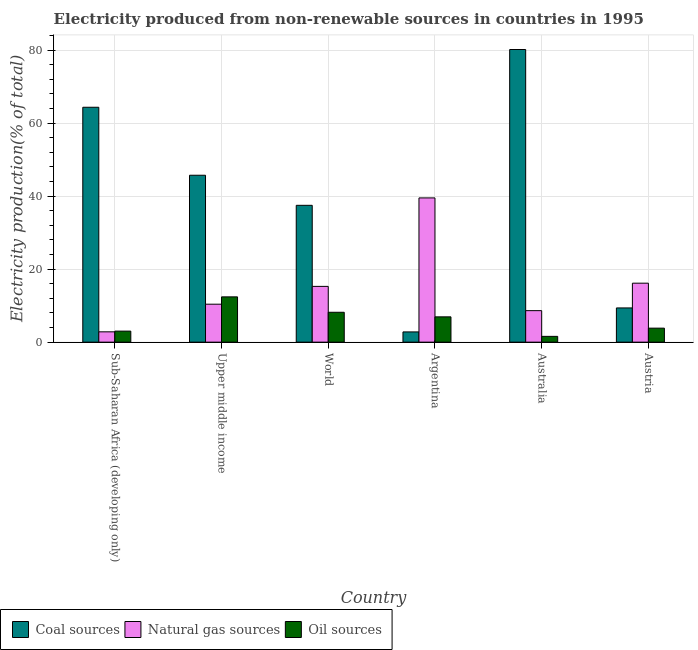How many different coloured bars are there?
Make the answer very short. 3. Are the number of bars per tick equal to the number of legend labels?
Ensure brevity in your answer.  Yes. How many bars are there on the 5th tick from the right?
Provide a short and direct response. 3. What is the label of the 5th group of bars from the left?
Offer a terse response. Australia. In how many cases, is the number of bars for a given country not equal to the number of legend labels?
Your response must be concise. 0. What is the percentage of electricity produced by natural gas in Austria?
Provide a short and direct response. 16.15. Across all countries, what is the maximum percentage of electricity produced by natural gas?
Ensure brevity in your answer.  39.51. Across all countries, what is the minimum percentage of electricity produced by coal?
Keep it short and to the point. 2.8. In which country was the percentage of electricity produced by natural gas minimum?
Your answer should be compact. Sub-Saharan Africa (developing only). What is the total percentage of electricity produced by oil sources in the graph?
Ensure brevity in your answer.  35.96. What is the difference between the percentage of electricity produced by oil sources in Upper middle income and that in World?
Your answer should be compact. 4.22. What is the difference between the percentage of electricity produced by natural gas in Argentina and the percentage of electricity produced by oil sources in Sub-Saharan Africa (developing only)?
Give a very brief answer. 36.49. What is the average percentage of electricity produced by coal per country?
Give a very brief answer. 39.98. What is the difference between the percentage of electricity produced by oil sources and percentage of electricity produced by natural gas in Austria?
Provide a succinct answer. -12.31. In how many countries, is the percentage of electricity produced by coal greater than 56 %?
Ensure brevity in your answer.  2. What is the ratio of the percentage of electricity produced by coal in Upper middle income to that in World?
Your answer should be compact. 1.22. Is the percentage of electricity produced by coal in Australia less than that in Sub-Saharan Africa (developing only)?
Give a very brief answer. No. What is the difference between the highest and the second highest percentage of electricity produced by coal?
Ensure brevity in your answer.  15.82. What is the difference between the highest and the lowest percentage of electricity produced by coal?
Ensure brevity in your answer.  77.36. In how many countries, is the percentage of electricity produced by coal greater than the average percentage of electricity produced by coal taken over all countries?
Your answer should be very brief. 3. Is the sum of the percentage of electricity produced by coal in Austria and Sub-Saharan Africa (developing only) greater than the maximum percentage of electricity produced by oil sources across all countries?
Ensure brevity in your answer.  Yes. What does the 1st bar from the left in Austria represents?
Offer a terse response. Coal sources. What does the 1st bar from the right in World represents?
Your response must be concise. Oil sources. How many bars are there?
Offer a very short reply. 18. Are all the bars in the graph horizontal?
Provide a succinct answer. No. Where does the legend appear in the graph?
Ensure brevity in your answer.  Bottom left. What is the title of the graph?
Ensure brevity in your answer.  Electricity produced from non-renewable sources in countries in 1995. Does "Argument" appear as one of the legend labels in the graph?
Make the answer very short. No. What is the label or title of the X-axis?
Offer a very short reply. Country. What is the label or title of the Y-axis?
Offer a terse response. Electricity production(% of total). What is the Electricity production(% of total) in Coal sources in Sub-Saharan Africa (developing only)?
Provide a succinct answer. 64.34. What is the Electricity production(% of total) in Natural gas sources in Sub-Saharan Africa (developing only)?
Ensure brevity in your answer.  2.82. What is the Electricity production(% of total) of Oil sources in Sub-Saharan Africa (developing only)?
Provide a succinct answer. 3.02. What is the Electricity production(% of total) in Coal sources in Upper middle income?
Ensure brevity in your answer.  45.72. What is the Electricity production(% of total) of Natural gas sources in Upper middle income?
Provide a succinct answer. 10.4. What is the Electricity production(% of total) of Oil sources in Upper middle income?
Offer a terse response. 12.4. What is the Electricity production(% of total) of Coal sources in World?
Your response must be concise. 37.48. What is the Electricity production(% of total) in Natural gas sources in World?
Offer a very short reply. 15.27. What is the Electricity production(% of total) of Oil sources in World?
Offer a terse response. 8.18. What is the Electricity production(% of total) of Coal sources in Argentina?
Keep it short and to the point. 2.8. What is the Electricity production(% of total) in Natural gas sources in Argentina?
Your answer should be very brief. 39.51. What is the Electricity production(% of total) in Oil sources in Argentina?
Provide a short and direct response. 6.93. What is the Electricity production(% of total) in Coal sources in Australia?
Your answer should be very brief. 80.16. What is the Electricity production(% of total) of Natural gas sources in Australia?
Make the answer very short. 8.63. What is the Electricity production(% of total) in Oil sources in Australia?
Offer a terse response. 1.58. What is the Electricity production(% of total) in Coal sources in Austria?
Provide a short and direct response. 9.38. What is the Electricity production(% of total) of Natural gas sources in Austria?
Your response must be concise. 16.15. What is the Electricity production(% of total) of Oil sources in Austria?
Offer a very short reply. 3.84. Across all countries, what is the maximum Electricity production(% of total) in Coal sources?
Your response must be concise. 80.16. Across all countries, what is the maximum Electricity production(% of total) in Natural gas sources?
Your answer should be very brief. 39.51. Across all countries, what is the maximum Electricity production(% of total) of Oil sources?
Your answer should be very brief. 12.4. Across all countries, what is the minimum Electricity production(% of total) in Coal sources?
Make the answer very short. 2.8. Across all countries, what is the minimum Electricity production(% of total) of Natural gas sources?
Ensure brevity in your answer.  2.82. Across all countries, what is the minimum Electricity production(% of total) in Oil sources?
Give a very brief answer. 1.58. What is the total Electricity production(% of total) in Coal sources in the graph?
Ensure brevity in your answer.  239.88. What is the total Electricity production(% of total) of Natural gas sources in the graph?
Provide a short and direct response. 92.79. What is the total Electricity production(% of total) in Oil sources in the graph?
Make the answer very short. 35.96. What is the difference between the Electricity production(% of total) in Coal sources in Sub-Saharan Africa (developing only) and that in Upper middle income?
Make the answer very short. 18.63. What is the difference between the Electricity production(% of total) of Natural gas sources in Sub-Saharan Africa (developing only) and that in Upper middle income?
Ensure brevity in your answer.  -7.57. What is the difference between the Electricity production(% of total) of Oil sources in Sub-Saharan Africa (developing only) and that in Upper middle income?
Provide a succinct answer. -9.38. What is the difference between the Electricity production(% of total) in Coal sources in Sub-Saharan Africa (developing only) and that in World?
Ensure brevity in your answer.  26.86. What is the difference between the Electricity production(% of total) of Natural gas sources in Sub-Saharan Africa (developing only) and that in World?
Your answer should be compact. -12.45. What is the difference between the Electricity production(% of total) of Oil sources in Sub-Saharan Africa (developing only) and that in World?
Provide a short and direct response. -5.16. What is the difference between the Electricity production(% of total) in Coal sources in Sub-Saharan Africa (developing only) and that in Argentina?
Ensure brevity in your answer.  61.54. What is the difference between the Electricity production(% of total) of Natural gas sources in Sub-Saharan Africa (developing only) and that in Argentina?
Provide a short and direct response. -36.68. What is the difference between the Electricity production(% of total) in Oil sources in Sub-Saharan Africa (developing only) and that in Argentina?
Your answer should be compact. -3.91. What is the difference between the Electricity production(% of total) of Coal sources in Sub-Saharan Africa (developing only) and that in Australia?
Your answer should be very brief. -15.82. What is the difference between the Electricity production(% of total) of Natural gas sources in Sub-Saharan Africa (developing only) and that in Australia?
Offer a very short reply. -5.81. What is the difference between the Electricity production(% of total) of Oil sources in Sub-Saharan Africa (developing only) and that in Australia?
Give a very brief answer. 1.44. What is the difference between the Electricity production(% of total) in Coal sources in Sub-Saharan Africa (developing only) and that in Austria?
Your answer should be compact. 54.97. What is the difference between the Electricity production(% of total) in Natural gas sources in Sub-Saharan Africa (developing only) and that in Austria?
Your answer should be compact. -13.33. What is the difference between the Electricity production(% of total) of Oil sources in Sub-Saharan Africa (developing only) and that in Austria?
Your answer should be compact. -0.81. What is the difference between the Electricity production(% of total) of Coal sources in Upper middle income and that in World?
Ensure brevity in your answer.  8.24. What is the difference between the Electricity production(% of total) of Natural gas sources in Upper middle income and that in World?
Offer a terse response. -4.88. What is the difference between the Electricity production(% of total) of Oil sources in Upper middle income and that in World?
Your response must be concise. 4.22. What is the difference between the Electricity production(% of total) of Coal sources in Upper middle income and that in Argentina?
Your answer should be compact. 42.91. What is the difference between the Electricity production(% of total) in Natural gas sources in Upper middle income and that in Argentina?
Give a very brief answer. -29.11. What is the difference between the Electricity production(% of total) in Oil sources in Upper middle income and that in Argentina?
Provide a short and direct response. 5.47. What is the difference between the Electricity production(% of total) of Coal sources in Upper middle income and that in Australia?
Your answer should be very brief. -34.44. What is the difference between the Electricity production(% of total) of Natural gas sources in Upper middle income and that in Australia?
Offer a terse response. 1.77. What is the difference between the Electricity production(% of total) in Oil sources in Upper middle income and that in Australia?
Make the answer very short. 10.82. What is the difference between the Electricity production(% of total) of Coal sources in Upper middle income and that in Austria?
Provide a succinct answer. 36.34. What is the difference between the Electricity production(% of total) in Natural gas sources in Upper middle income and that in Austria?
Ensure brevity in your answer.  -5.75. What is the difference between the Electricity production(% of total) in Oil sources in Upper middle income and that in Austria?
Offer a very short reply. 8.57. What is the difference between the Electricity production(% of total) in Coal sources in World and that in Argentina?
Provide a succinct answer. 34.68. What is the difference between the Electricity production(% of total) in Natural gas sources in World and that in Argentina?
Your answer should be very brief. -24.24. What is the difference between the Electricity production(% of total) in Oil sources in World and that in Argentina?
Ensure brevity in your answer.  1.25. What is the difference between the Electricity production(% of total) in Coal sources in World and that in Australia?
Your response must be concise. -42.68. What is the difference between the Electricity production(% of total) of Natural gas sources in World and that in Australia?
Offer a very short reply. 6.64. What is the difference between the Electricity production(% of total) of Oil sources in World and that in Australia?
Make the answer very short. 6.6. What is the difference between the Electricity production(% of total) of Coal sources in World and that in Austria?
Provide a succinct answer. 28.1. What is the difference between the Electricity production(% of total) of Natural gas sources in World and that in Austria?
Ensure brevity in your answer.  -0.88. What is the difference between the Electricity production(% of total) in Oil sources in World and that in Austria?
Provide a short and direct response. 4.35. What is the difference between the Electricity production(% of total) in Coal sources in Argentina and that in Australia?
Offer a terse response. -77.36. What is the difference between the Electricity production(% of total) of Natural gas sources in Argentina and that in Australia?
Your response must be concise. 30.88. What is the difference between the Electricity production(% of total) of Oil sources in Argentina and that in Australia?
Your response must be concise. 5.35. What is the difference between the Electricity production(% of total) in Coal sources in Argentina and that in Austria?
Keep it short and to the point. -6.57. What is the difference between the Electricity production(% of total) of Natural gas sources in Argentina and that in Austria?
Provide a succinct answer. 23.36. What is the difference between the Electricity production(% of total) of Oil sources in Argentina and that in Austria?
Your response must be concise. 3.09. What is the difference between the Electricity production(% of total) of Coal sources in Australia and that in Austria?
Offer a very short reply. 70.79. What is the difference between the Electricity production(% of total) of Natural gas sources in Australia and that in Austria?
Provide a succinct answer. -7.52. What is the difference between the Electricity production(% of total) in Oil sources in Australia and that in Austria?
Offer a very short reply. -2.25. What is the difference between the Electricity production(% of total) in Coal sources in Sub-Saharan Africa (developing only) and the Electricity production(% of total) in Natural gas sources in Upper middle income?
Keep it short and to the point. 53.95. What is the difference between the Electricity production(% of total) of Coal sources in Sub-Saharan Africa (developing only) and the Electricity production(% of total) of Oil sources in Upper middle income?
Keep it short and to the point. 51.94. What is the difference between the Electricity production(% of total) of Natural gas sources in Sub-Saharan Africa (developing only) and the Electricity production(% of total) of Oil sources in Upper middle income?
Provide a succinct answer. -9.58. What is the difference between the Electricity production(% of total) of Coal sources in Sub-Saharan Africa (developing only) and the Electricity production(% of total) of Natural gas sources in World?
Keep it short and to the point. 49.07. What is the difference between the Electricity production(% of total) in Coal sources in Sub-Saharan Africa (developing only) and the Electricity production(% of total) in Oil sources in World?
Make the answer very short. 56.16. What is the difference between the Electricity production(% of total) in Natural gas sources in Sub-Saharan Africa (developing only) and the Electricity production(% of total) in Oil sources in World?
Offer a terse response. -5.36. What is the difference between the Electricity production(% of total) in Coal sources in Sub-Saharan Africa (developing only) and the Electricity production(% of total) in Natural gas sources in Argentina?
Ensure brevity in your answer.  24.83. What is the difference between the Electricity production(% of total) in Coal sources in Sub-Saharan Africa (developing only) and the Electricity production(% of total) in Oil sources in Argentina?
Make the answer very short. 57.41. What is the difference between the Electricity production(% of total) of Natural gas sources in Sub-Saharan Africa (developing only) and the Electricity production(% of total) of Oil sources in Argentina?
Give a very brief answer. -4.11. What is the difference between the Electricity production(% of total) of Coal sources in Sub-Saharan Africa (developing only) and the Electricity production(% of total) of Natural gas sources in Australia?
Make the answer very short. 55.71. What is the difference between the Electricity production(% of total) of Coal sources in Sub-Saharan Africa (developing only) and the Electricity production(% of total) of Oil sources in Australia?
Offer a very short reply. 62.76. What is the difference between the Electricity production(% of total) of Natural gas sources in Sub-Saharan Africa (developing only) and the Electricity production(% of total) of Oil sources in Australia?
Give a very brief answer. 1.24. What is the difference between the Electricity production(% of total) in Coal sources in Sub-Saharan Africa (developing only) and the Electricity production(% of total) in Natural gas sources in Austria?
Your answer should be compact. 48.19. What is the difference between the Electricity production(% of total) of Coal sources in Sub-Saharan Africa (developing only) and the Electricity production(% of total) of Oil sources in Austria?
Provide a succinct answer. 60.51. What is the difference between the Electricity production(% of total) of Natural gas sources in Sub-Saharan Africa (developing only) and the Electricity production(% of total) of Oil sources in Austria?
Give a very brief answer. -1.01. What is the difference between the Electricity production(% of total) of Coal sources in Upper middle income and the Electricity production(% of total) of Natural gas sources in World?
Provide a succinct answer. 30.44. What is the difference between the Electricity production(% of total) of Coal sources in Upper middle income and the Electricity production(% of total) of Oil sources in World?
Keep it short and to the point. 37.53. What is the difference between the Electricity production(% of total) of Natural gas sources in Upper middle income and the Electricity production(% of total) of Oil sources in World?
Your answer should be very brief. 2.21. What is the difference between the Electricity production(% of total) in Coal sources in Upper middle income and the Electricity production(% of total) in Natural gas sources in Argentina?
Provide a short and direct response. 6.21. What is the difference between the Electricity production(% of total) in Coal sources in Upper middle income and the Electricity production(% of total) in Oil sources in Argentina?
Give a very brief answer. 38.79. What is the difference between the Electricity production(% of total) of Natural gas sources in Upper middle income and the Electricity production(% of total) of Oil sources in Argentina?
Ensure brevity in your answer.  3.47. What is the difference between the Electricity production(% of total) in Coal sources in Upper middle income and the Electricity production(% of total) in Natural gas sources in Australia?
Make the answer very short. 37.09. What is the difference between the Electricity production(% of total) of Coal sources in Upper middle income and the Electricity production(% of total) of Oil sources in Australia?
Your response must be concise. 44.13. What is the difference between the Electricity production(% of total) in Natural gas sources in Upper middle income and the Electricity production(% of total) in Oil sources in Australia?
Your response must be concise. 8.81. What is the difference between the Electricity production(% of total) in Coal sources in Upper middle income and the Electricity production(% of total) in Natural gas sources in Austria?
Offer a very short reply. 29.57. What is the difference between the Electricity production(% of total) of Coal sources in Upper middle income and the Electricity production(% of total) of Oil sources in Austria?
Offer a very short reply. 41.88. What is the difference between the Electricity production(% of total) in Natural gas sources in Upper middle income and the Electricity production(% of total) in Oil sources in Austria?
Offer a terse response. 6.56. What is the difference between the Electricity production(% of total) of Coal sources in World and the Electricity production(% of total) of Natural gas sources in Argentina?
Provide a short and direct response. -2.03. What is the difference between the Electricity production(% of total) in Coal sources in World and the Electricity production(% of total) in Oil sources in Argentina?
Offer a terse response. 30.55. What is the difference between the Electricity production(% of total) in Natural gas sources in World and the Electricity production(% of total) in Oil sources in Argentina?
Give a very brief answer. 8.34. What is the difference between the Electricity production(% of total) in Coal sources in World and the Electricity production(% of total) in Natural gas sources in Australia?
Ensure brevity in your answer.  28.85. What is the difference between the Electricity production(% of total) in Coal sources in World and the Electricity production(% of total) in Oil sources in Australia?
Provide a succinct answer. 35.9. What is the difference between the Electricity production(% of total) of Natural gas sources in World and the Electricity production(% of total) of Oil sources in Australia?
Your response must be concise. 13.69. What is the difference between the Electricity production(% of total) in Coal sources in World and the Electricity production(% of total) in Natural gas sources in Austria?
Offer a terse response. 21.33. What is the difference between the Electricity production(% of total) of Coal sources in World and the Electricity production(% of total) of Oil sources in Austria?
Give a very brief answer. 33.64. What is the difference between the Electricity production(% of total) in Natural gas sources in World and the Electricity production(% of total) in Oil sources in Austria?
Make the answer very short. 11.44. What is the difference between the Electricity production(% of total) in Coal sources in Argentina and the Electricity production(% of total) in Natural gas sources in Australia?
Offer a terse response. -5.83. What is the difference between the Electricity production(% of total) of Coal sources in Argentina and the Electricity production(% of total) of Oil sources in Australia?
Offer a terse response. 1.22. What is the difference between the Electricity production(% of total) in Natural gas sources in Argentina and the Electricity production(% of total) in Oil sources in Australia?
Provide a succinct answer. 37.92. What is the difference between the Electricity production(% of total) in Coal sources in Argentina and the Electricity production(% of total) in Natural gas sources in Austria?
Your response must be concise. -13.35. What is the difference between the Electricity production(% of total) in Coal sources in Argentina and the Electricity production(% of total) in Oil sources in Austria?
Give a very brief answer. -1.03. What is the difference between the Electricity production(% of total) of Natural gas sources in Argentina and the Electricity production(% of total) of Oil sources in Austria?
Your answer should be very brief. 35.67. What is the difference between the Electricity production(% of total) of Coal sources in Australia and the Electricity production(% of total) of Natural gas sources in Austria?
Provide a short and direct response. 64.01. What is the difference between the Electricity production(% of total) in Coal sources in Australia and the Electricity production(% of total) in Oil sources in Austria?
Your answer should be very brief. 76.32. What is the difference between the Electricity production(% of total) in Natural gas sources in Australia and the Electricity production(% of total) in Oil sources in Austria?
Your answer should be very brief. 4.79. What is the average Electricity production(% of total) in Coal sources per country?
Ensure brevity in your answer.  39.98. What is the average Electricity production(% of total) of Natural gas sources per country?
Keep it short and to the point. 15.46. What is the average Electricity production(% of total) in Oil sources per country?
Your response must be concise. 5.99. What is the difference between the Electricity production(% of total) in Coal sources and Electricity production(% of total) in Natural gas sources in Sub-Saharan Africa (developing only)?
Your answer should be compact. 61.52. What is the difference between the Electricity production(% of total) in Coal sources and Electricity production(% of total) in Oil sources in Sub-Saharan Africa (developing only)?
Make the answer very short. 61.32. What is the difference between the Electricity production(% of total) in Natural gas sources and Electricity production(% of total) in Oil sources in Sub-Saharan Africa (developing only)?
Provide a short and direct response. -0.2. What is the difference between the Electricity production(% of total) of Coal sources and Electricity production(% of total) of Natural gas sources in Upper middle income?
Offer a very short reply. 35.32. What is the difference between the Electricity production(% of total) of Coal sources and Electricity production(% of total) of Oil sources in Upper middle income?
Your answer should be very brief. 33.31. What is the difference between the Electricity production(% of total) of Natural gas sources and Electricity production(% of total) of Oil sources in Upper middle income?
Your answer should be very brief. -2.01. What is the difference between the Electricity production(% of total) of Coal sources and Electricity production(% of total) of Natural gas sources in World?
Make the answer very short. 22.21. What is the difference between the Electricity production(% of total) of Coal sources and Electricity production(% of total) of Oil sources in World?
Keep it short and to the point. 29.29. What is the difference between the Electricity production(% of total) in Natural gas sources and Electricity production(% of total) in Oil sources in World?
Your answer should be compact. 7.09. What is the difference between the Electricity production(% of total) of Coal sources and Electricity production(% of total) of Natural gas sources in Argentina?
Your response must be concise. -36.71. What is the difference between the Electricity production(% of total) in Coal sources and Electricity production(% of total) in Oil sources in Argentina?
Keep it short and to the point. -4.13. What is the difference between the Electricity production(% of total) in Natural gas sources and Electricity production(% of total) in Oil sources in Argentina?
Provide a short and direct response. 32.58. What is the difference between the Electricity production(% of total) of Coal sources and Electricity production(% of total) of Natural gas sources in Australia?
Make the answer very short. 71.53. What is the difference between the Electricity production(% of total) in Coal sources and Electricity production(% of total) in Oil sources in Australia?
Your answer should be compact. 78.58. What is the difference between the Electricity production(% of total) of Natural gas sources and Electricity production(% of total) of Oil sources in Australia?
Your answer should be very brief. 7.05. What is the difference between the Electricity production(% of total) in Coal sources and Electricity production(% of total) in Natural gas sources in Austria?
Your answer should be compact. -6.78. What is the difference between the Electricity production(% of total) in Coal sources and Electricity production(% of total) in Oil sources in Austria?
Your response must be concise. 5.54. What is the difference between the Electricity production(% of total) of Natural gas sources and Electricity production(% of total) of Oil sources in Austria?
Ensure brevity in your answer.  12.31. What is the ratio of the Electricity production(% of total) in Coal sources in Sub-Saharan Africa (developing only) to that in Upper middle income?
Your answer should be compact. 1.41. What is the ratio of the Electricity production(% of total) of Natural gas sources in Sub-Saharan Africa (developing only) to that in Upper middle income?
Give a very brief answer. 0.27. What is the ratio of the Electricity production(% of total) of Oil sources in Sub-Saharan Africa (developing only) to that in Upper middle income?
Provide a short and direct response. 0.24. What is the ratio of the Electricity production(% of total) in Coal sources in Sub-Saharan Africa (developing only) to that in World?
Make the answer very short. 1.72. What is the ratio of the Electricity production(% of total) of Natural gas sources in Sub-Saharan Africa (developing only) to that in World?
Ensure brevity in your answer.  0.18. What is the ratio of the Electricity production(% of total) in Oil sources in Sub-Saharan Africa (developing only) to that in World?
Provide a succinct answer. 0.37. What is the ratio of the Electricity production(% of total) in Coal sources in Sub-Saharan Africa (developing only) to that in Argentina?
Ensure brevity in your answer.  22.95. What is the ratio of the Electricity production(% of total) in Natural gas sources in Sub-Saharan Africa (developing only) to that in Argentina?
Offer a terse response. 0.07. What is the ratio of the Electricity production(% of total) in Oil sources in Sub-Saharan Africa (developing only) to that in Argentina?
Your response must be concise. 0.44. What is the ratio of the Electricity production(% of total) in Coal sources in Sub-Saharan Africa (developing only) to that in Australia?
Provide a succinct answer. 0.8. What is the ratio of the Electricity production(% of total) of Natural gas sources in Sub-Saharan Africa (developing only) to that in Australia?
Give a very brief answer. 0.33. What is the ratio of the Electricity production(% of total) in Oil sources in Sub-Saharan Africa (developing only) to that in Australia?
Your answer should be very brief. 1.91. What is the ratio of the Electricity production(% of total) in Coal sources in Sub-Saharan Africa (developing only) to that in Austria?
Your answer should be very brief. 6.86. What is the ratio of the Electricity production(% of total) of Natural gas sources in Sub-Saharan Africa (developing only) to that in Austria?
Your response must be concise. 0.17. What is the ratio of the Electricity production(% of total) of Oil sources in Sub-Saharan Africa (developing only) to that in Austria?
Offer a terse response. 0.79. What is the ratio of the Electricity production(% of total) in Coal sources in Upper middle income to that in World?
Offer a very short reply. 1.22. What is the ratio of the Electricity production(% of total) in Natural gas sources in Upper middle income to that in World?
Provide a succinct answer. 0.68. What is the ratio of the Electricity production(% of total) of Oil sources in Upper middle income to that in World?
Make the answer very short. 1.52. What is the ratio of the Electricity production(% of total) in Coal sources in Upper middle income to that in Argentina?
Provide a short and direct response. 16.31. What is the ratio of the Electricity production(% of total) of Natural gas sources in Upper middle income to that in Argentina?
Your response must be concise. 0.26. What is the ratio of the Electricity production(% of total) of Oil sources in Upper middle income to that in Argentina?
Your response must be concise. 1.79. What is the ratio of the Electricity production(% of total) in Coal sources in Upper middle income to that in Australia?
Offer a terse response. 0.57. What is the ratio of the Electricity production(% of total) in Natural gas sources in Upper middle income to that in Australia?
Ensure brevity in your answer.  1.2. What is the ratio of the Electricity production(% of total) in Oil sources in Upper middle income to that in Australia?
Offer a very short reply. 7.83. What is the ratio of the Electricity production(% of total) in Coal sources in Upper middle income to that in Austria?
Offer a very short reply. 4.88. What is the ratio of the Electricity production(% of total) of Natural gas sources in Upper middle income to that in Austria?
Keep it short and to the point. 0.64. What is the ratio of the Electricity production(% of total) in Oil sources in Upper middle income to that in Austria?
Your answer should be very brief. 3.23. What is the ratio of the Electricity production(% of total) in Coal sources in World to that in Argentina?
Provide a succinct answer. 13.37. What is the ratio of the Electricity production(% of total) in Natural gas sources in World to that in Argentina?
Ensure brevity in your answer.  0.39. What is the ratio of the Electricity production(% of total) of Oil sources in World to that in Argentina?
Your answer should be very brief. 1.18. What is the ratio of the Electricity production(% of total) in Coal sources in World to that in Australia?
Make the answer very short. 0.47. What is the ratio of the Electricity production(% of total) in Natural gas sources in World to that in Australia?
Offer a terse response. 1.77. What is the ratio of the Electricity production(% of total) of Oil sources in World to that in Australia?
Ensure brevity in your answer.  5.17. What is the ratio of the Electricity production(% of total) of Coal sources in World to that in Austria?
Your answer should be compact. 4. What is the ratio of the Electricity production(% of total) of Natural gas sources in World to that in Austria?
Your answer should be very brief. 0.95. What is the ratio of the Electricity production(% of total) in Oil sources in World to that in Austria?
Provide a short and direct response. 2.13. What is the ratio of the Electricity production(% of total) of Coal sources in Argentina to that in Australia?
Your answer should be compact. 0.04. What is the ratio of the Electricity production(% of total) of Natural gas sources in Argentina to that in Australia?
Your answer should be compact. 4.58. What is the ratio of the Electricity production(% of total) of Oil sources in Argentina to that in Australia?
Provide a short and direct response. 4.37. What is the ratio of the Electricity production(% of total) in Coal sources in Argentina to that in Austria?
Make the answer very short. 0.3. What is the ratio of the Electricity production(% of total) of Natural gas sources in Argentina to that in Austria?
Keep it short and to the point. 2.45. What is the ratio of the Electricity production(% of total) of Oil sources in Argentina to that in Austria?
Give a very brief answer. 1.81. What is the ratio of the Electricity production(% of total) of Coal sources in Australia to that in Austria?
Make the answer very short. 8.55. What is the ratio of the Electricity production(% of total) of Natural gas sources in Australia to that in Austria?
Provide a succinct answer. 0.53. What is the ratio of the Electricity production(% of total) in Oil sources in Australia to that in Austria?
Provide a short and direct response. 0.41. What is the difference between the highest and the second highest Electricity production(% of total) of Coal sources?
Offer a terse response. 15.82. What is the difference between the highest and the second highest Electricity production(% of total) of Natural gas sources?
Keep it short and to the point. 23.36. What is the difference between the highest and the second highest Electricity production(% of total) of Oil sources?
Provide a succinct answer. 4.22. What is the difference between the highest and the lowest Electricity production(% of total) in Coal sources?
Your response must be concise. 77.36. What is the difference between the highest and the lowest Electricity production(% of total) in Natural gas sources?
Offer a terse response. 36.68. What is the difference between the highest and the lowest Electricity production(% of total) in Oil sources?
Your answer should be very brief. 10.82. 